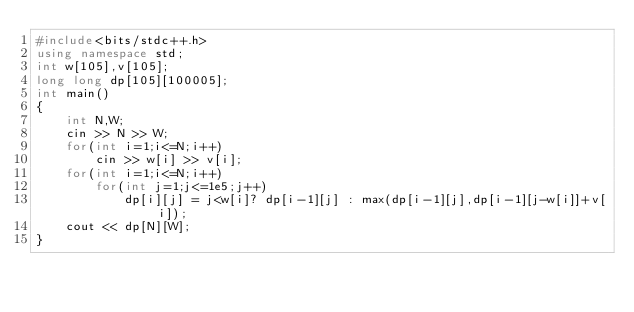<code> <loc_0><loc_0><loc_500><loc_500><_C++_>#include<bits/stdc++.h>
using namespace std;
int w[105],v[105];
long long dp[105][100005];
int main()
{
    int N,W;
    cin >> N >> W;
    for(int i=1;i<=N;i++)
        cin >> w[i] >> v[i];
    for(int i=1;i<=N;i++)
        for(int j=1;j<=1e5;j++)
            dp[i][j] = j<w[i]? dp[i-1][j] : max(dp[i-1][j],dp[i-1][j-w[i]]+v[i]);
    cout << dp[N][W];
}
</code> 